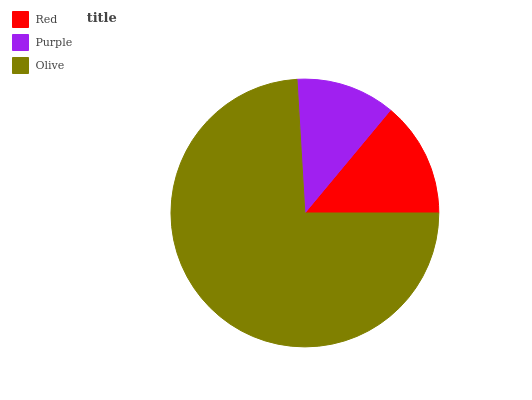Is Purple the minimum?
Answer yes or no. Yes. Is Olive the maximum?
Answer yes or no. Yes. Is Olive the minimum?
Answer yes or no. No. Is Purple the maximum?
Answer yes or no. No. Is Olive greater than Purple?
Answer yes or no. Yes. Is Purple less than Olive?
Answer yes or no. Yes. Is Purple greater than Olive?
Answer yes or no. No. Is Olive less than Purple?
Answer yes or no. No. Is Red the high median?
Answer yes or no. Yes. Is Red the low median?
Answer yes or no. Yes. Is Olive the high median?
Answer yes or no. No. Is Olive the low median?
Answer yes or no. No. 